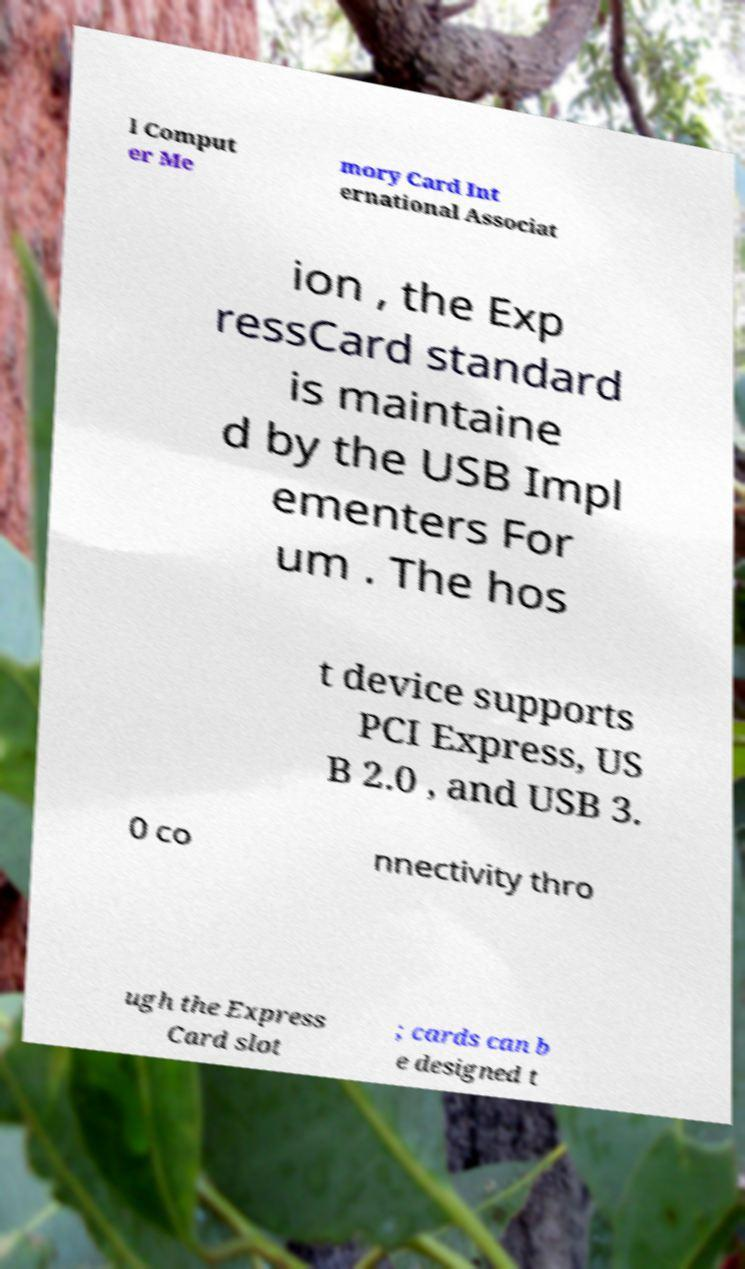Could you assist in decoding the text presented in this image and type it out clearly? l Comput er Me mory Card Int ernational Associat ion , the Exp ressCard standard is maintaine d by the USB Impl ementers For um . The hos t device supports PCI Express, US B 2.0 , and USB 3. 0 co nnectivity thro ugh the Express Card slot ; cards can b e designed t 